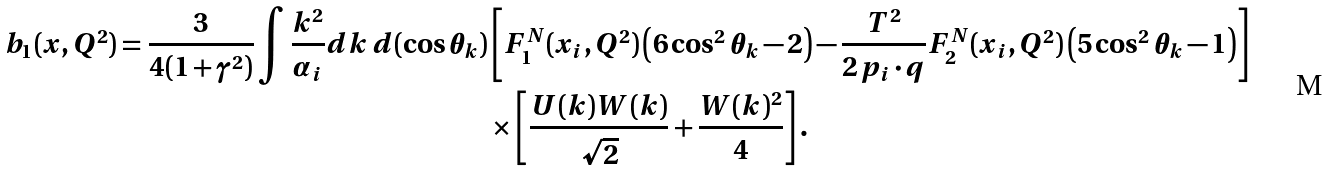<formula> <loc_0><loc_0><loc_500><loc_500>b _ { 1 } ( x , Q ^ { 2 } ) = \frac { 3 } { 4 ( 1 + \gamma ^ { 2 } ) } \int \frac { k ^ { 2 } } { \alpha _ { i } } d k \, d ( \cos \theta _ { k } ) & \left [ F _ { 1 } ^ { N } ( x _ { i } , Q ^ { 2 } ) \left ( 6 \cos ^ { 2 } \theta _ { k } - 2 \right ) - \frac { T ^ { 2 } } { 2 \, p _ { i } \cdot q } F _ { 2 } ^ { N } ( x _ { i } , Q ^ { 2 } ) \left ( 5 \cos ^ { 2 } \theta _ { k } - 1 \right ) \right ] \\ & \times \left [ \frac { U ( k ) W ( k ) } { \sqrt { 2 } } + \frac { W ( k ) ^ { 2 } } { 4 } \right ] .</formula> 